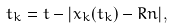<formula> <loc_0><loc_0><loc_500><loc_500>t _ { k } = t - | x _ { k } ( t _ { k } ) - R n | ,</formula> 